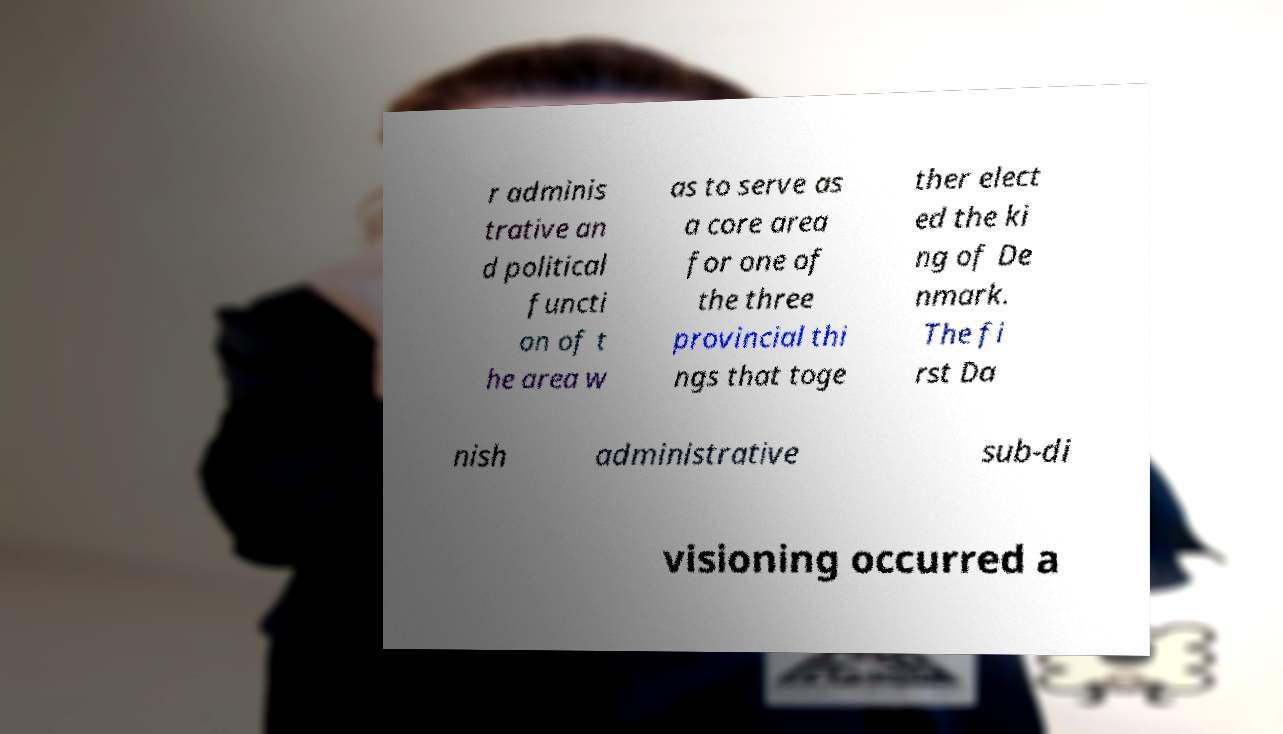Can you read and provide the text displayed in the image?This photo seems to have some interesting text. Can you extract and type it out for me? r adminis trative an d political functi on of t he area w as to serve as a core area for one of the three provincial thi ngs that toge ther elect ed the ki ng of De nmark. The fi rst Da nish administrative sub-di visioning occurred a 